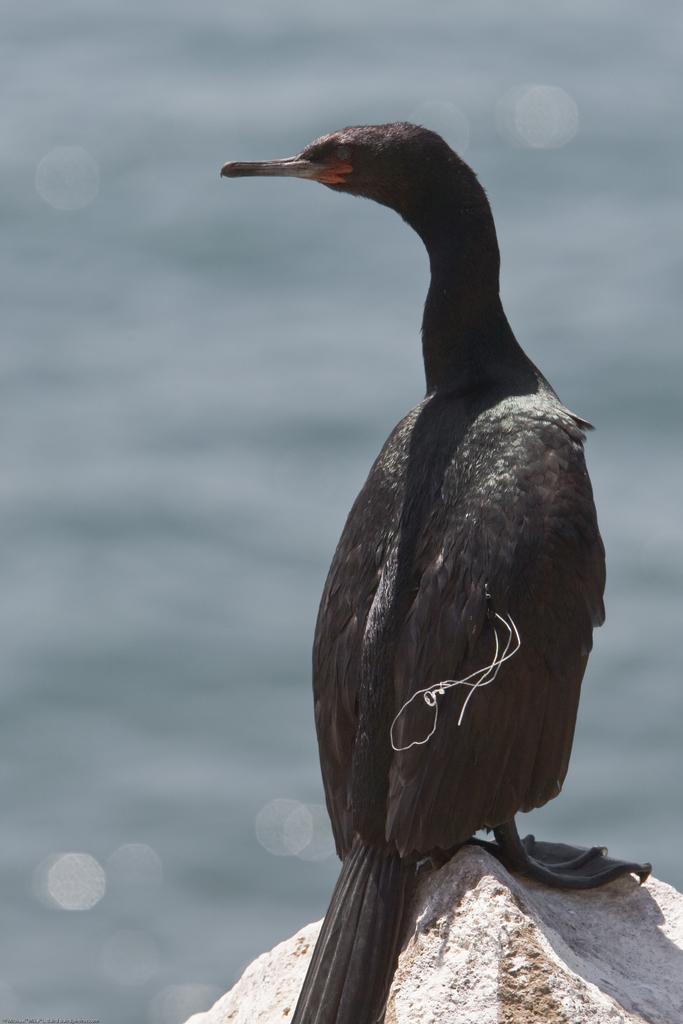In one or two sentences, can you explain what this image depicts? In this image, we can see a bird on the rock. We can also see the blurred background. 